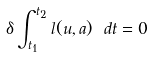<formula> <loc_0><loc_0><loc_500><loc_500>\delta \int _ { t _ { 1 } } ^ { t _ { 2 } } l ( u , a ) \ d t = 0</formula> 